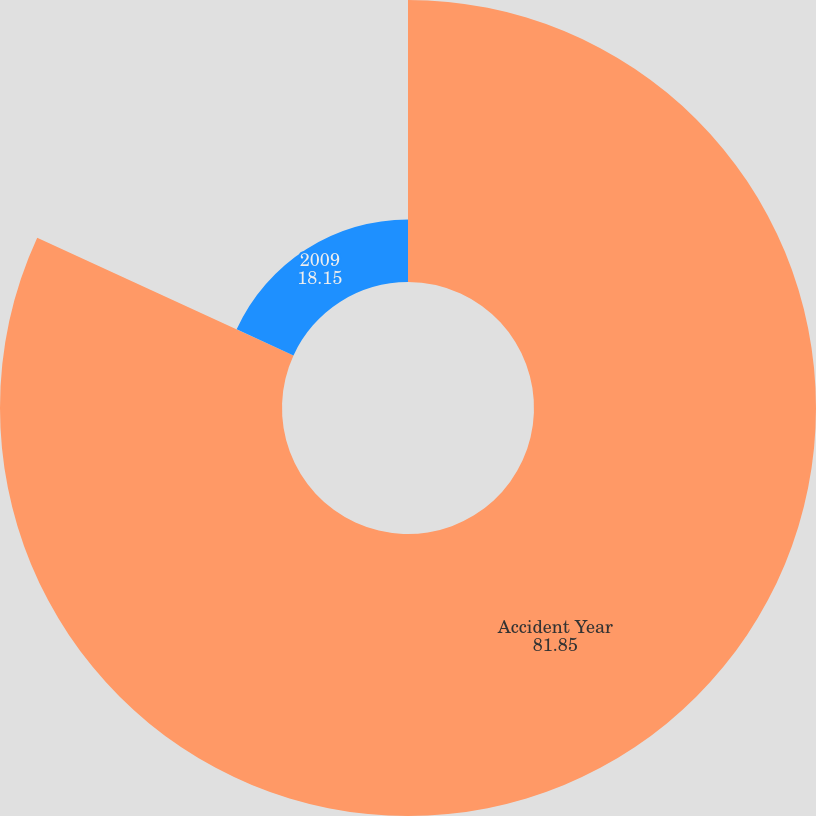Convert chart. <chart><loc_0><loc_0><loc_500><loc_500><pie_chart><fcel>Accident Year<fcel>2009<nl><fcel>81.85%<fcel>18.15%<nl></chart> 